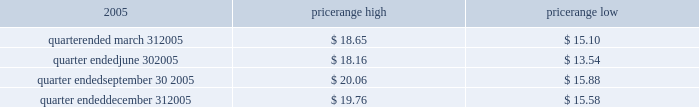Item 4 .
Submission of matters to a vote of security holders no matters were submitted to a vote of security holders during the fourth quarter of 2005 .
Part ii item 5 .
Market for the registrant 2019s common equity , related stockholder matters and issuer purchases of equity securities market information our series a common stock has traded on the new york stock exchange under the symbol 2018 2018ce 2019 2019 since january 21 , 2005 .
The closing sale price of our series a common stock , as reported by the new york stock exchange , on march 6 , 2006 was $ 20.98 .
The table sets forth the high and low intraday sales prices per share of our common stock , as reported by the new york stock exchange , for the periods indicated. .
Holders no shares of celanese 2019s series b common stock are issued and outstanding .
As of march 6 , 2006 , there were 51 holders of record of our series a common stock , and one holder of record of our perpetual preferred stock .
By including persons holding shares in broker accounts under street names , however , we estimate our shareholder base to be approximately 6800 as of march 6 , 2006 .
Dividend policy in july 2005 , our board of directors adopted a policy of declaring , subject to legally available funds , a quarterly cash dividend on each share of our common stock at an annual rate initially equal to approximately 1% ( 1 % ) of the $ 16 price per share in the initial public offering of our series a common stock ( or $ 0.16 per share ) unless our board of directors , in its sole discretion , determines otherwise , commencing the second quarter of 2005 .
Pursuant to this policy , the company paid the quarterly dividends of $ 0.04 per share on august 11 , 2005 , november 1 , 2005 and february 1 , 2006 .
Based on the number of outstanding shares of our series a common stock , the anticipated annual cash dividend is approximately $ 25 million .
However , there is no assurance that sufficient cash will be available in the future to pay such dividend .
Further , such dividends payable to holders of our series a common stock cannot be declared or paid nor can any funds be set aside for the payment thereof , unless we have paid or set aside funds for the payment of all accumulated and unpaid dividends with respect to the shares of our preferred stock , as described below .
Our board of directors may , at any time , modify or revoke our dividend policy on our series a common stock .
We are required under the terms of the preferred stock to pay scheduled quarterly dividends , subject to legally available funds .
For so long as the preferred stock remains outstanding , ( 1 ) we will not declare , pay or set apart funds for the payment of any dividend or other distribution with respect to any junior stock or parity stock and ( 2 ) neither we , nor any of our subsidiaries , will , subject to certain exceptions , redeem , purchase or otherwise acquire for consideration junior stock or parity stock through a sinking fund or otherwise , in each case unless we have paid or set apart funds for the payment of all accumulated and unpaid dividends with respect to the shares of preferred stock and any parity stock for all preceding dividend periods .
Pursuant to this policy , the company paid the quarterly dividends of $ 0.265625 on its 4.25% ( 4.25 % ) convertible perpetual preferred stock on august 1 , 2005 , november 1 , 2005 and february 1 , 2006 .
The anticipated annual cash dividend is approximately $ 10 million. .
What is the estimated number of shares of series a common stock based on the approximate cash dividend in millions? 
Rationale: to get the number of shouts of series a common stock you divide the total annual cash dividend by the dividend amount
Computations: (25 / 0.16)
Answer: 156.25. 